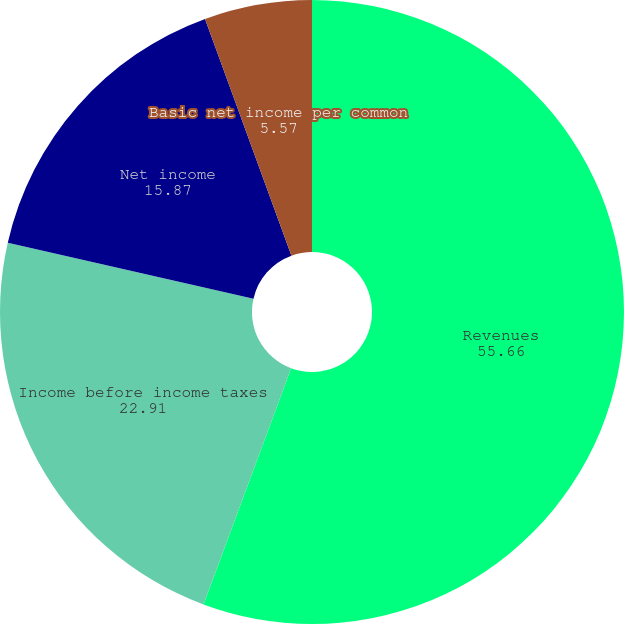Convert chart. <chart><loc_0><loc_0><loc_500><loc_500><pie_chart><fcel>Revenues<fcel>Income before income taxes<fcel>Net income<fcel>Basic net income per common<fcel>Diluted net income per common<nl><fcel>55.66%<fcel>22.91%<fcel>15.87%<fcel>5.57%<fcel>0.0%<nl></chart> 